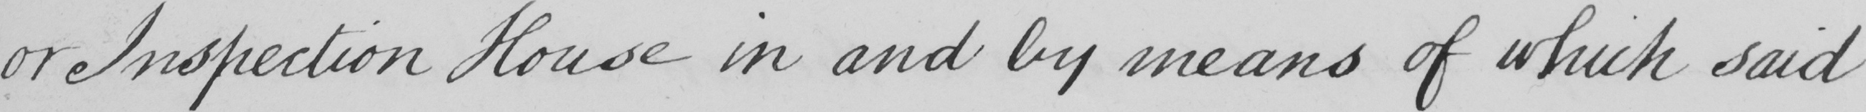Transcribe the text shown in this historical manuscript line. or Inspection House in and by means of which said 